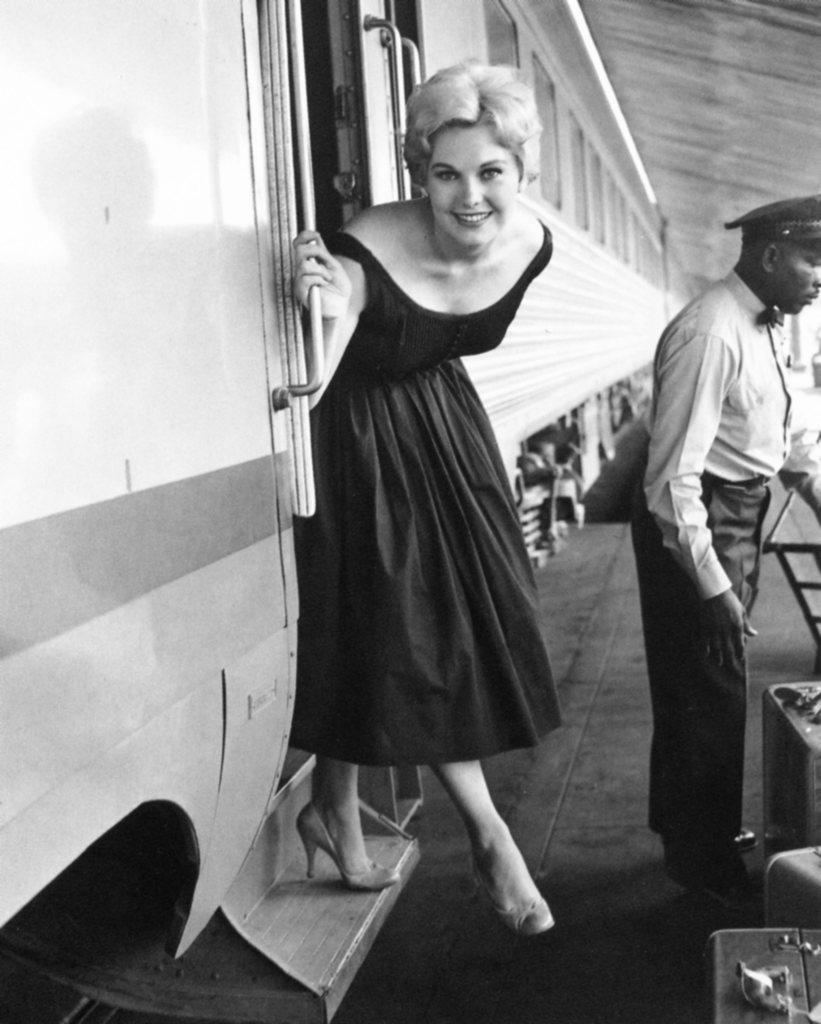What is the color scheme of the image? The image is black and white. What is the main subject of the image? There are women on a train in the center of the image. What else can be seen on the right side of the image? There are persons standing on the right side of the image. What type of screw is being used by the women on the train in the image? There is no screw visible in the image; it features women on a train and persons standing nearby. What hobbies do the women on the train have, as depicted in the image? The image does not provide information about the hobbies of the women on the train. 